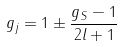<formula> <loc_0><loc_0><loc_500><loc_500>g _ { j } = 1 \pm \frac { g _ { S } - 1 } { 2 l + 1 }</formula> 